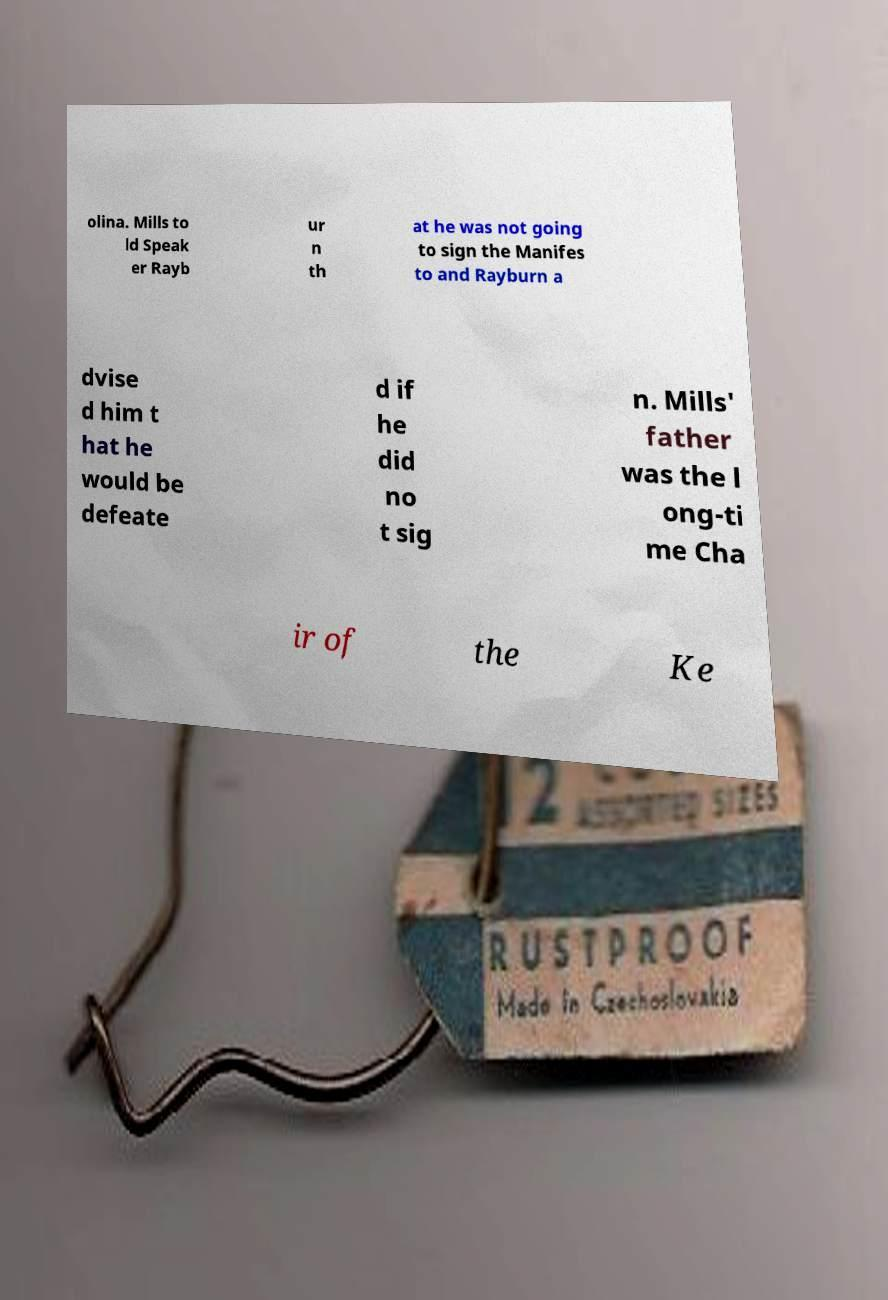Could you assist in decoding the text presented in this image and type it out clearly? olina. Mills to ld Speak er Rayb ur n th at he was not going to sign the Manifes to and Rayburn a dvise d him t hat he would be defeate d if he did no t sig n. Mills' father was the l ong-ti me Cha ir of the Ke 